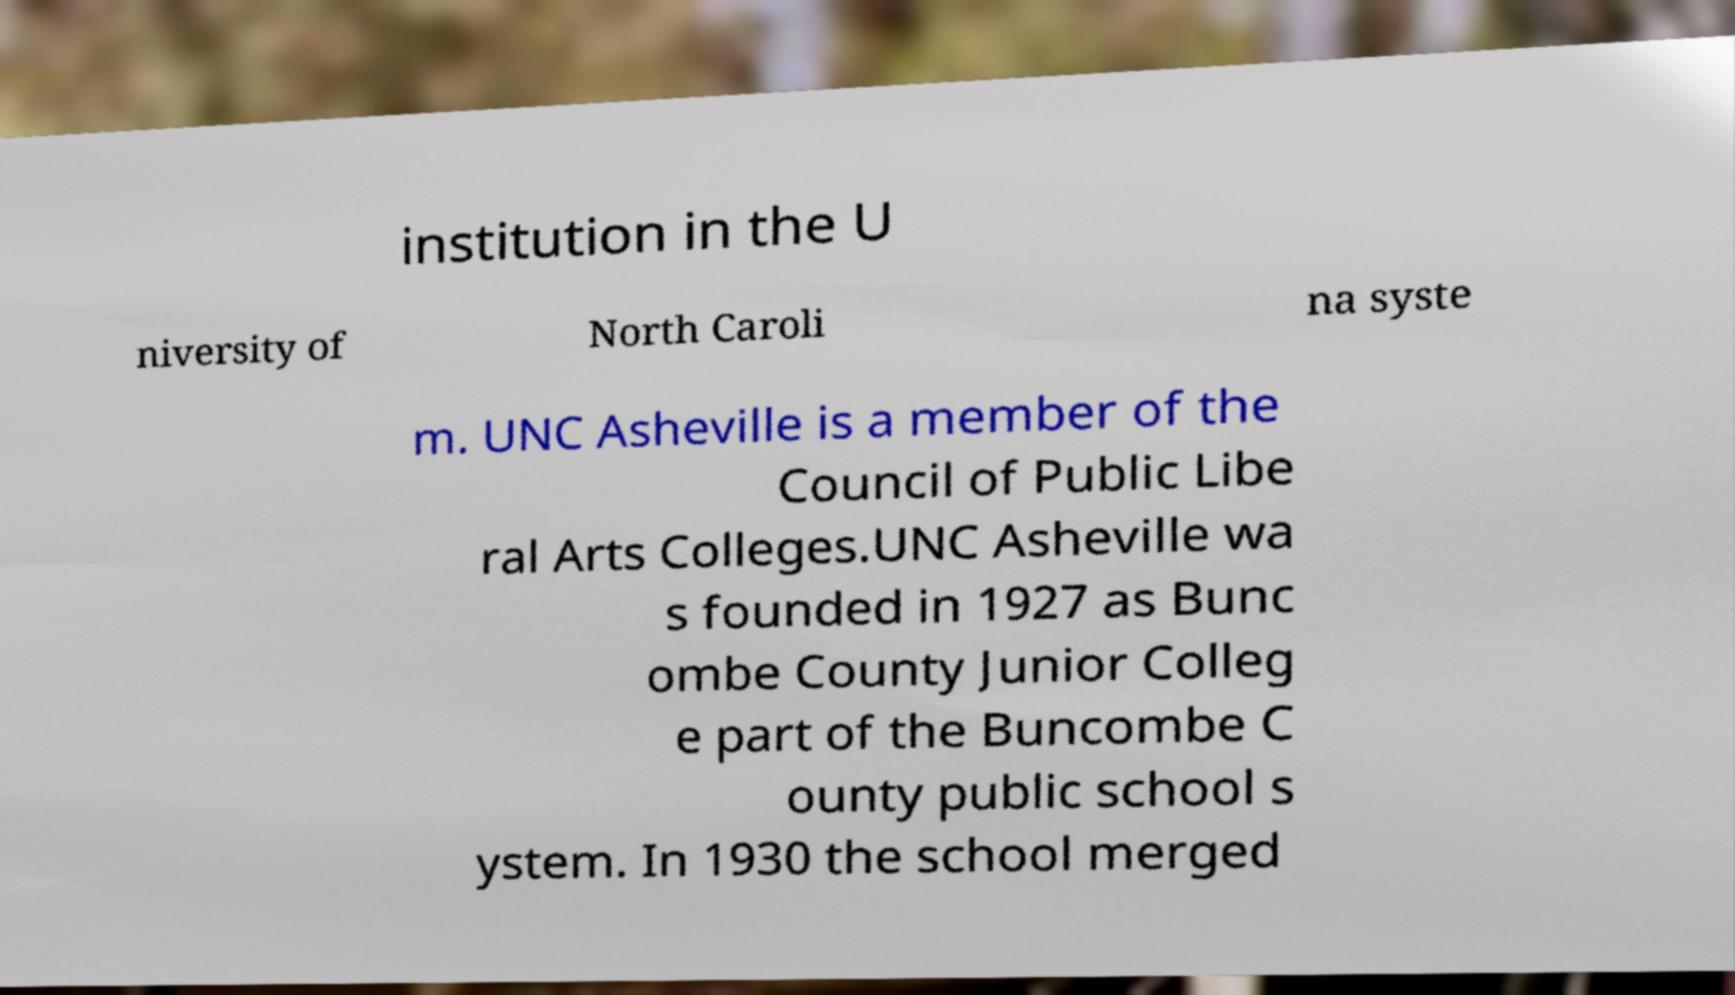There's text embedded in this image that I need extracted. Can you transcribe it verbatim? institution in the U niversity of North Caroli na syste m. UNC Asheville is a member of the Council of Public Libe ral Arts Colleges.UNC Asheville wa s founded in 1927 as Bunc ombe County Junior Colleg e part of the Buncombe C ounty public school s ystem. In 1930 the school merged 